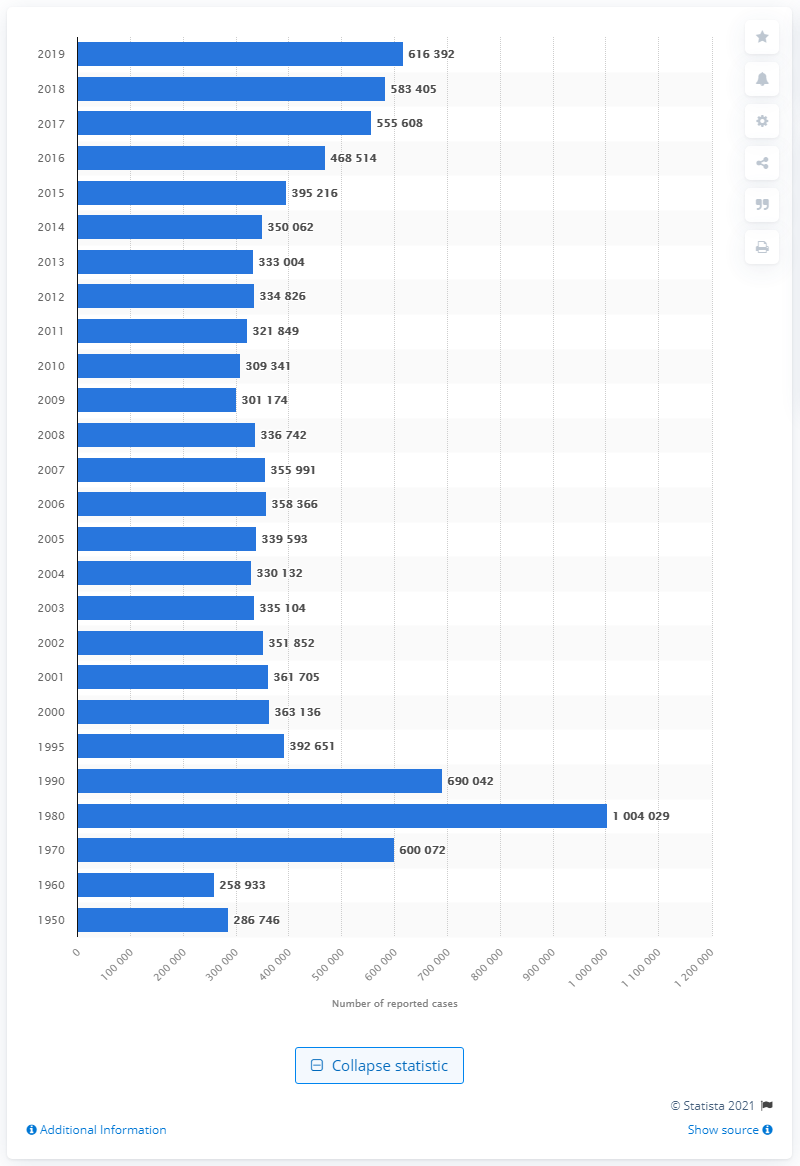Highlight a few significant elements in this photo. In 1980, the highest number of cases of gonorrhea were reported. 